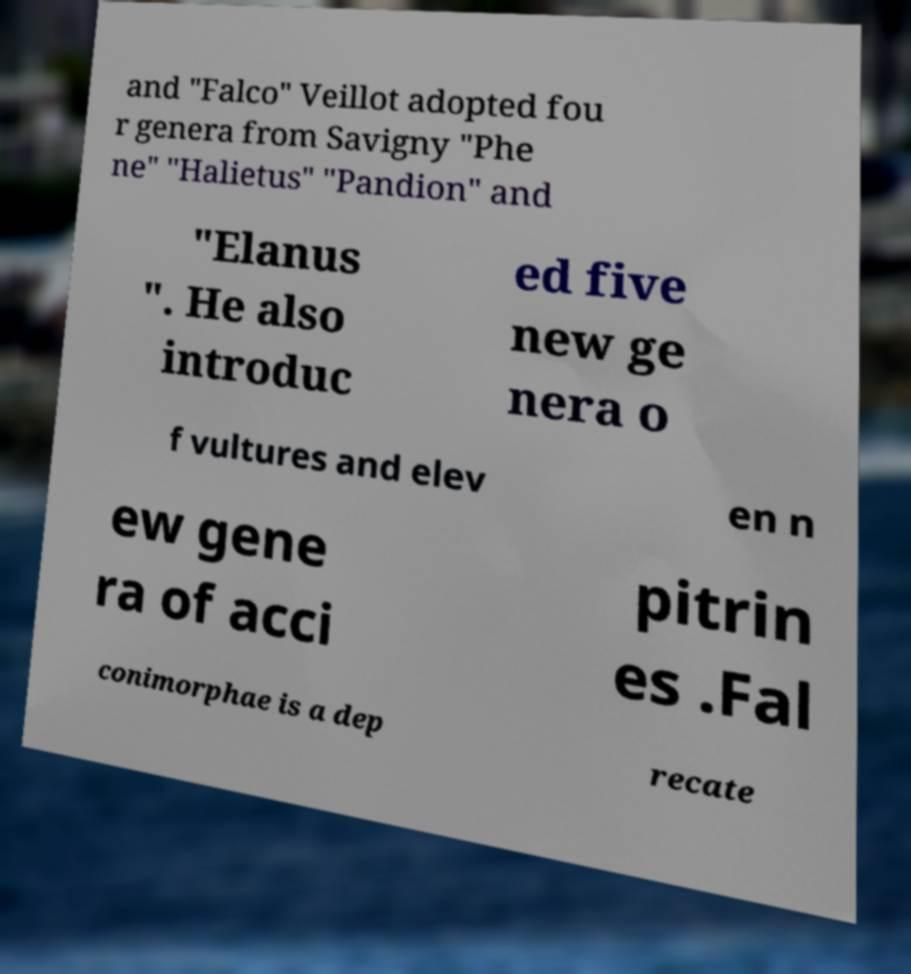Please identify and transcribe the text found in this image. and "Falco" Veillot adopted fou r genera from Savigny "Phe ne" "Halietus" "Pandion" and "Elanus ". He also introduc ed five new ge nera o f vultures and elev en n ew gene ra of acci pitrin es .Fal conimorphae is a dep recate 